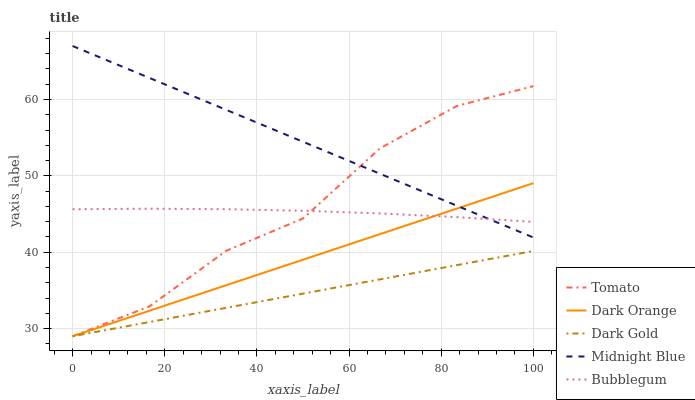Does Dark Gold have the minimum area under the curve?
Answer yes or no. Yes. Does Midnight Blue have the maximum area under the curve?
Answer yes or no. Yes. Does Dark Orange have the minimum area under the curve?
Answer yes or no. No. Does Dark Orange have the maximum area under the curve?
Answer yes or no. No. Is Dark Orange the smoothest?
Answer yes or no. Yes. Is Tomato the roughest?
Answer yes or no. Yes. Is Midnight Blue the smoothest?
Answer yes or no. No. Is Midnight Blue the roughest?
Answer yes or no. No. Does Tomato have the lowest value?
Answer yes or no. Yes. Does Midnight Blue have the lowest value?
Answer yes or no. No. Does Midnight Blue have the highest value?
Answer yes or no. Yes. Does Dark Orange have the highest value?
Answer yes or no. No. Is Dark Gold less than Midnight Blue?
Answer yes or no. Yes. Is Midnight Blue greater than Dark Gold?
Answer yes or no. Yes. Does Dark Orange intersect Dark Gold?
Answer yes or no. Yes. Is Dark Orange less than Dark Gold?
Answer yes or no. No. Is Dark Orange greater than Dark Gold?
Answer yes or no. No. Does Dark Gold intersect Midnight Blue?
Answer yes or no. No. 